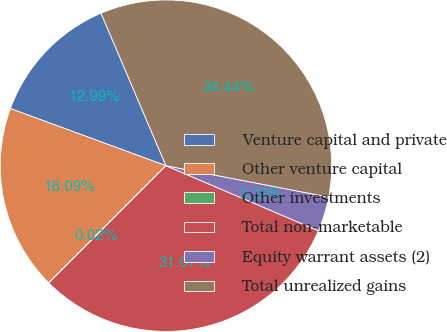Convert chart. <chart><loc_0><loc_0><loc_500><loc_500><pie_chart><fcel>Venture capital and private<fcel>Other venture capital<fcel>Other investments<fcel>Total non-marketable<fcel>Equity warrant assets (2)<fcel>Total unrealized gains<nl><fcel>12.99%<fcel>18.09%<fcel>0.02%<fcel>31.07%<fcel>3.39%<fcel>34.44%<nl></chart> 